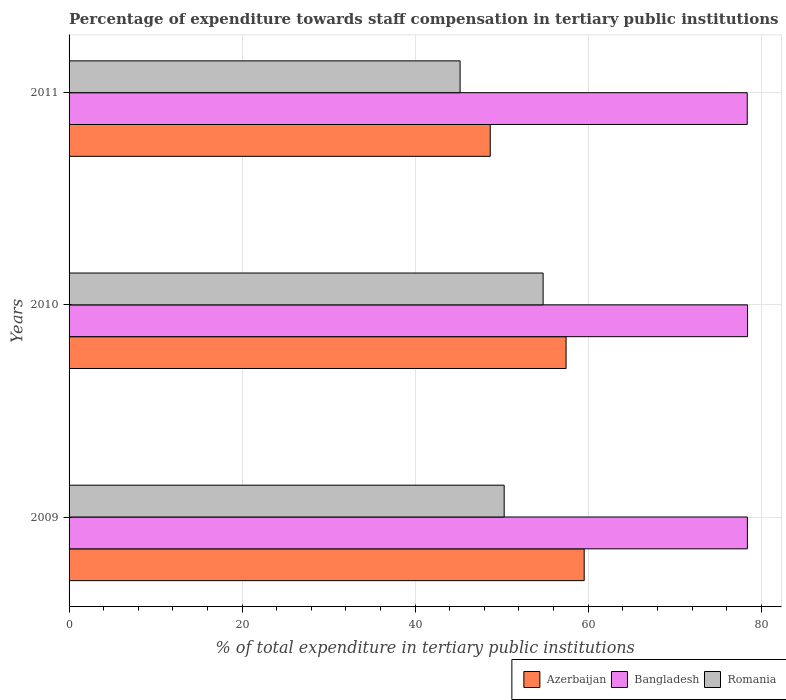How many bars are there on the 1st tick from the top?
Make the answer very short. 3. What is the label of the 1st group of bars from the top?
Keep it short and to the point. 2011. What is the percentage of expenditure towards staff compensation in Romania in 2011?
Your answer should be very brief. 45.19. Across all years, what is the maximum percentage of expenditure towards staff compensation in Bangladesh?
Offer a very short reply. 78.42. Across all years, what is the minimum percentage of expenditure towards staff compensation in Azerbaijan?
Provide a succinct answer. 48.68. In which year was the percentage of expenditure towards staff compensation in Romania minimum?
Your response must be concise. 2011. What is the total percentage of expenditure towards staff compensation in Romania in the graph?
Offer a terse response. 150.27. What is the difference between the percentage of expenditure towards staff compensation in Bangladesh in 2009 and that in 2011?
Offer a terse response. 0.02. What is the difference between the percentage of expenditure towards staff compensation in Romania in 2009 and the percentage of expenditure towards staff compensation in Azerbaijan in 2011?
Offer a terse response. 1.61. What is the average percentage of expenditure towards staff compensation in Bangladesh per year?
Provide a short and direct response. 78.4. In the year 2010, what is the difference between the percentage of expenditure towards staff compensation in Bangladesh and percentage of expenditure towards staff compensation in Azerbaijan?
Your answer should be very brief. 20.98. What is the ratio of the percentage of expenditure towards staff compensation in Bangladesh in 2009 to that in 2010?
Your answer should be very brief. 1. Is the difference between the percentage of expenditure towards staff compensation in Bangladesh in 2010 and 2011 greater than the difference between the percentage of expenditure towards staff compensation in Azerbaijan in 2010 and 2011?
Make the answer very short. No. What is the difference between the highest and the second highest percentage of expenditure towards staff compensation in Bangladesh?
Make the answer very short. 0.02. What is the difference between the highest and the lowest percentage of expenditure towards staff compensation in Azerbaijan?
Provide a succinct answer. 10.86. In how many years, is the percentage of expenditure towards staff compensation in Bangladesh greater than the average percentage of expenditure towards staff compensation in Bangladesh taken over all years?
Provide a succinct answer. 1. Is the sum of the percentage of expenditure towards staff compensation in Azerbaijan in 2009 and 2010 greater than the maximum percentage of expenditure towards staff compensation in Bangladesh across all years?
Your answer should be compact. Yes. What does the 2nd bar from the top in 2009 represents?
Give a very brief answer. Bangladesh. Are all the bars in the graph horizontal?
Make the answer very short. Yes. What is the difference between two consecutive major ticks on the X-axis?
Provide a short and direct response. 20. How many legend labels are there?
Keep it short and to the point. 3. How are the legend labels stacked?
Your answer should be compact. Horizontal. What is the title of the graph?
Your response must be concise. Percentage of expenditure towards staff compensation in tertiary public institutions. Does "Guam" appear as one of the legend labels in the graph?
Your response must be concise. No. What is the label or title of the X-axis?
Your response must be concise. % of total expenditure in tertiary public institutions. What is the label or title of the Y-axis?
Your answer should be compact. Years. What is the % of total expenditure in tertiary public institutions in Azerbaijan in 2009?
Ensure brevity in your answer.  59.54. What is the % of total expenditure in tertiary public institutions of Bangladesh in 2009?
Ensure brevity in your answer.  78.4. What is the % of total expenditure in tertiary public institutions of Romania in 2009?
Your answer should be compact. 50.29. What is the % of total expenditure in tertiary public institutions of Azerbaijan in 2010?
Your response must be concise. 57.44. What is the % of total expenditure in tertiary public institutions of Bangladesh in 2010?
Give a very brief answer. 78.42. What is the % of total expenditure in tertiary public institutions of Romania in 2010?
Your response must be concise. 54.79. What is the % of total expenditure in tertiary public institutions in Azerbaijan in 2011?
Keep it short and to the point. 48.68. What is the % of total expenditure in tertiary public institutions of Bangladesh in 2011?
Provide a short and direct response. 78.38. What is the % of total expenditure in tertiary public institutions in Romania in 2011?
Your answer should be compact. 45.19. Across all years, what is the maximum % of total expenditure in tertiary public institutions in Azerbaijan?
Make the answer very short. 59.54. Across all years, what is the maximum % of total expenditure in tertiary public institutions of Bangladesh?
Provide a succinct answer. 78.42. Across all years, what is the maximum % of total expenditure in tertiary public institutions in Romania?
Your answer should be very brief. 54.79. Across all years, what is the minimum % of total expenditure in tertiary public institutions in Azerbaijan?
Your response must be concise. 48.68. Across all years, what is the minimum % of total expenditure in tertiary public institutions in Bangladesh?
Ensure brevity in your answer.  78.38. Across all years, what is the minimum % of total expenditure in tertiary public institutions in Romania?
Ensure brevity in your answer.  45.19. What is the total % of total expenditure in tertiary public institutions of Azerbaijan in the graph?
Provide a succinct answer. 165.66. What is the total % of total expenditure in tertiary public institutions in Bangladesh in the graph?
Give a very brief answer. 235.2. What is the total % of total expenditure in tertiary public institutions of Romania in the graph?
Your answer should be very brief. 150.27. What is the difference between the % of total expenditure in tertiary public institutions of Azerbaijan in 2009 and that in 2010?
Keep it short and to the point. 2.09. What is the difference between the % of total expenditure in tertiary public institutions in Bangladesh in 2009 and that in 2010?
Provide a succinct answer. -0.02. What is the difference between the % of total expenditure in tertiary public institutions in Romania in 2009 and that in 2010?
Provide a succinct answer. -4.5. What is the difference between the % of total expenditure in tertiary public institutions in Azerbaijan in 2009 and that in 2011?
Provide a succinct answer. 10.86. What is the difference between the % of total expenditure in tertiary public institutions in Bangladesh in 2009 and that in 2011?
Keep it short and to the point. 0.02. What is the difference between the % of total expenditure in tertiary public institutions in Romania in 2009 and that in 2011?
Your response must be concise. 5.09. What is the difference between the % of total expenditure in tertiary public institutions in Azerbaijan in 2010 and that in 2011?
Offer a terse response. 8.76. What is the difference between the % of total expenditure in tertiary public institutions in Bangladesh in 2010 and that in 2011?
Your response must be concise. 0.04. What is the difference between the % of total expenditure in tertiary public institutions of Romania in 2010 and that in 2011?
Ensure brevity in your answer.  9.6. What is the difference between the % of total expenditure in tertiary public institutions in Azerbaijan in 2009 and the % of total expenditure in tertiary public institutions in Bangladesh in 2010?
Offer a terse response. -18.88. What is the difference between the % of total expenditure in tertiary public institutions of Azerbaijan in 2009 and the % of total expenditure in tertiary public institutions of Romania in 2010?
Offer a terse response. 4.75. What is the difference between the % of total expenditure in tertiary public institutions of Bangladesh in 2009 and the % of total expenditure in tertiary public institutions of Romania in 2010?
Provide a succinct answer. 23.61. What is the difference between the % of total expenditure in tertiary public institutions in Azerbaijan in 2009 and the % of total expenditure in tertiary public institutions in Bangladesh in 2011?
Offer a very short reply. -18.84. What is the difference between the % of total expenditure in tertiary public institutions in Azerbaijan in 2009 and the % of total expenditure in tertiary public institutions in Romania in 2011?
Offer a very short reply. 14.34. What is the difference between the % of total expenditure in tertiary public institutions in Bangladesh in 2009 and the % of total expenditure in tertiary public institutions in Romania in 2011?
Your response must be concise. 33.2. What is the difference between the % of total expenditure in tertiary public institutions in Azerbaijan in 2010 and the % of total expenditure in tertiary public institutions in Bangladesh in 2011?
Offer a very short reply. -20.94. What is the difference between the % of total expenditure in tertiary public institutions of Azerbaijan in 2010 and the % of total expenditure in tertiary public institutions of Romania in 2011?
Your answer should be very brief. 12.25. What is the difference between the % of total expenditure in tertiary public institutions in Bangladesh in 2010 and the % of total expenditure in tertiary public institutions in Romania in 2011?
Your answer should be very brief. 33.23. What is the average % of total expenditure in tertiary public institutions in Azerbaijan per year?
Offer a very short reply. 55.22. What is the average % of total expenditure in tertiary public institutions in Bangladesh per year?
Provide a succinct answer. 78.4. What is the average % of total expenditure in tertiary public institutions of Romania per year?
Give a very brief answer. 50.09. In the year 2009, what is the difference between the % of total expenditure in tertiary public institutions of Azerbaijan and % of total expenditure in tertiary public institutions of Bangladesh?
Your response must be concise. -18.86. In the year 2009, what is the difference between the % of total expenditure in tertiary public institutions of Azerbaijan and % of total expenditure in tertiary public institutions of Romania?
Your answer should be compact. 9.25. In the year 2009, what is the difference between the % of total expenditure in tertiary public institutions of Bangladesh and % of total expenditure in tertiary public institutions of Romania?
Provide a succinct answer. 28.11. In the year 2010, what is the difference between the % of total expenditure in tertiary public institutions of Azerbaijan and % of total expenditure in tertiary public institutions of Bangladesh?
Offer a very short reply. -20.98. In the year 2010, what is the difference between the % of total expenditure in tertiary public institutions in Azerbaijan and % of total expenditure in tertiary public institutions in Romania?
Make the answer very short. 2.65. In the year 2010, what is the difference between the % of total expenditure in tertiary public institutions of Bangladesh and % of total expenditure in tertiary public institutions of Romania?
Keep it short and to the point. 23.63. In the year 2011, what is the difference between the % of total expenditure in tertiary public institutions of Azerbaijan and % of total expenditure in tertiary public institutions of Bangladesh?
Provide a succinct answer. -29.7. In the year 2011, what is the difference between the % of total expenditure in tertiary public institutions in Azerbaijan and % of total expenditure in tertiary public institutions in Romania?
Keep it short and to the point. 3.49. In the year 2011, what is the difference between the % of total expenditure in tertiary public institutions of Bangladesh and % of total expenditure in tertiary public institutions of Romania?
Keep it short and to the point. 33.19. What is the ratio of the % of total expenditure in tertiary public institutions in Azerbaijan in 2009 to that in 2010?
Your answer should be very brief. 1.04. What is the ratio of the % of total expenditure in tertiary public institutions of Romania in 2009 to that in 2010?
Offer a terse response. 0.92. What is the ratio of the % of total expenditure in tertiary public institutions in Azerbaijan in 2009 to that in 2011?
Your response must be concise. 1.22. What is the ratio of the % of total expenditure in tertiary public institutions of Bangladesh in 2009 to that in 2011?
Make the answer very short. 1. What is the ratio of the % of total expenditure in tertiary public institutions of Romania in 2009 to that in 2011?
Offer a very short reply. 1.11. What is the ratio of the % of total expenditure in tertiary public institutions in Azerbaijan in 2010 to that in 2011?
Your response must be concise. 1.18. What is the ratio of the % of total expenditure in tertiary public institutions in Bangladesh in 2010 to that in 2011?
Give a very brief answer. 1. What is the ratio of the % of total expenditure in tertiary public institutions of Romania in 2010 to that in 2011?
Your answer should be very brief. 1.21. What is the difference between the highest and the second highest % of total expenditure in tertiary public institutions in Azerbaijan?
Keep it short and to the point. 2.09. What is the difference between the highest and the second highest % of total expenditure in tertiary public institutions of Bangladesh?
Your answer should be compact. 0.02. What is the difference between the highest and the second highest % of total expenditure in tertiary public institutions in Romania?
Provide a short and direct response. 4.5. What is the difference between the highest and the lowest % of total expenditure in tertiary public institutions of Azerbaijan?
Make the answer very short. 10.86. What is the difference between the highest and the lowest % of total expenditure in tertiary public institutions in Bangladesh?
Ensure brevity in your answer.  0.04. What is the difference between the highest and the lowest % of total expenditure in tertiary public institutions in Romania?
Your answer should be compact. 9.6. 